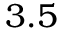Convert formula to latex. <formula><loc_0><loc_0><loc_500><loc_500>3 . 5</formula> 